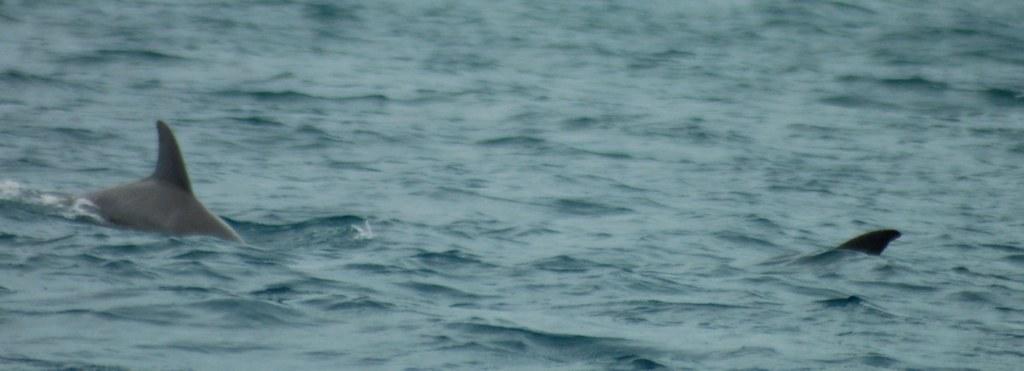Describe this image in one or two sentences. In this image I can see the water and two aquatic animals in the water. 